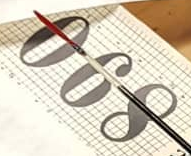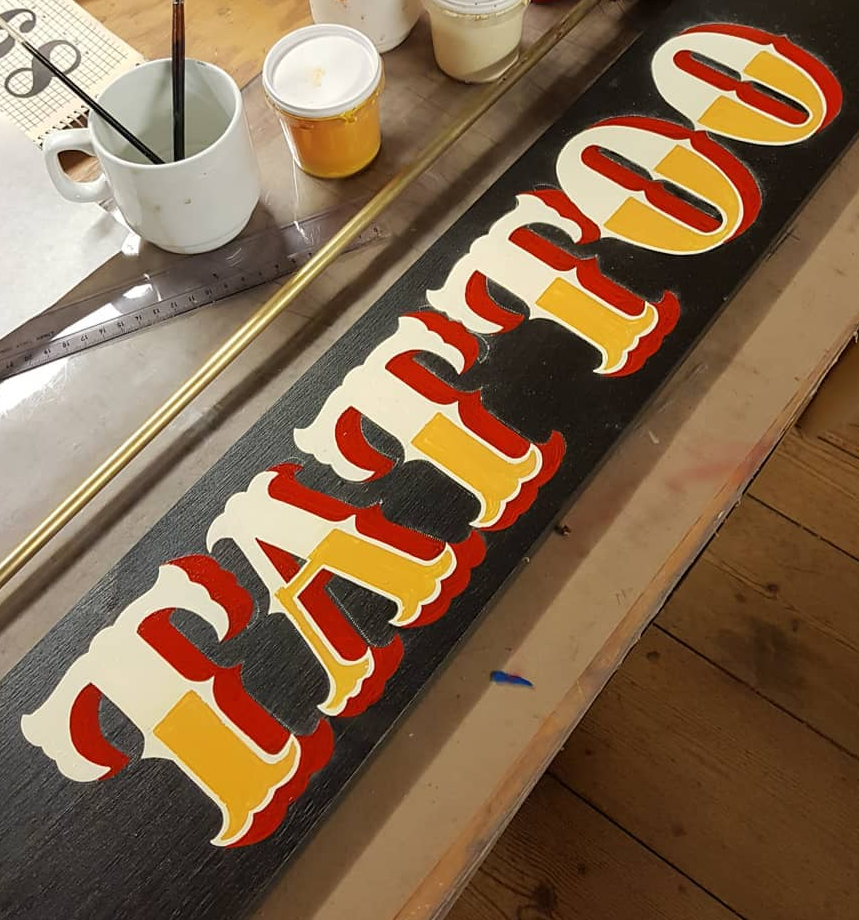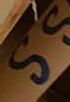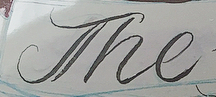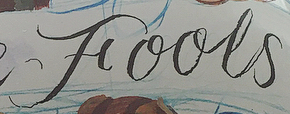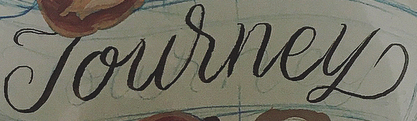What words are shown in these images in order, separated by a semicolon? 890; TATTOO; SS; The; Fools; Journey 